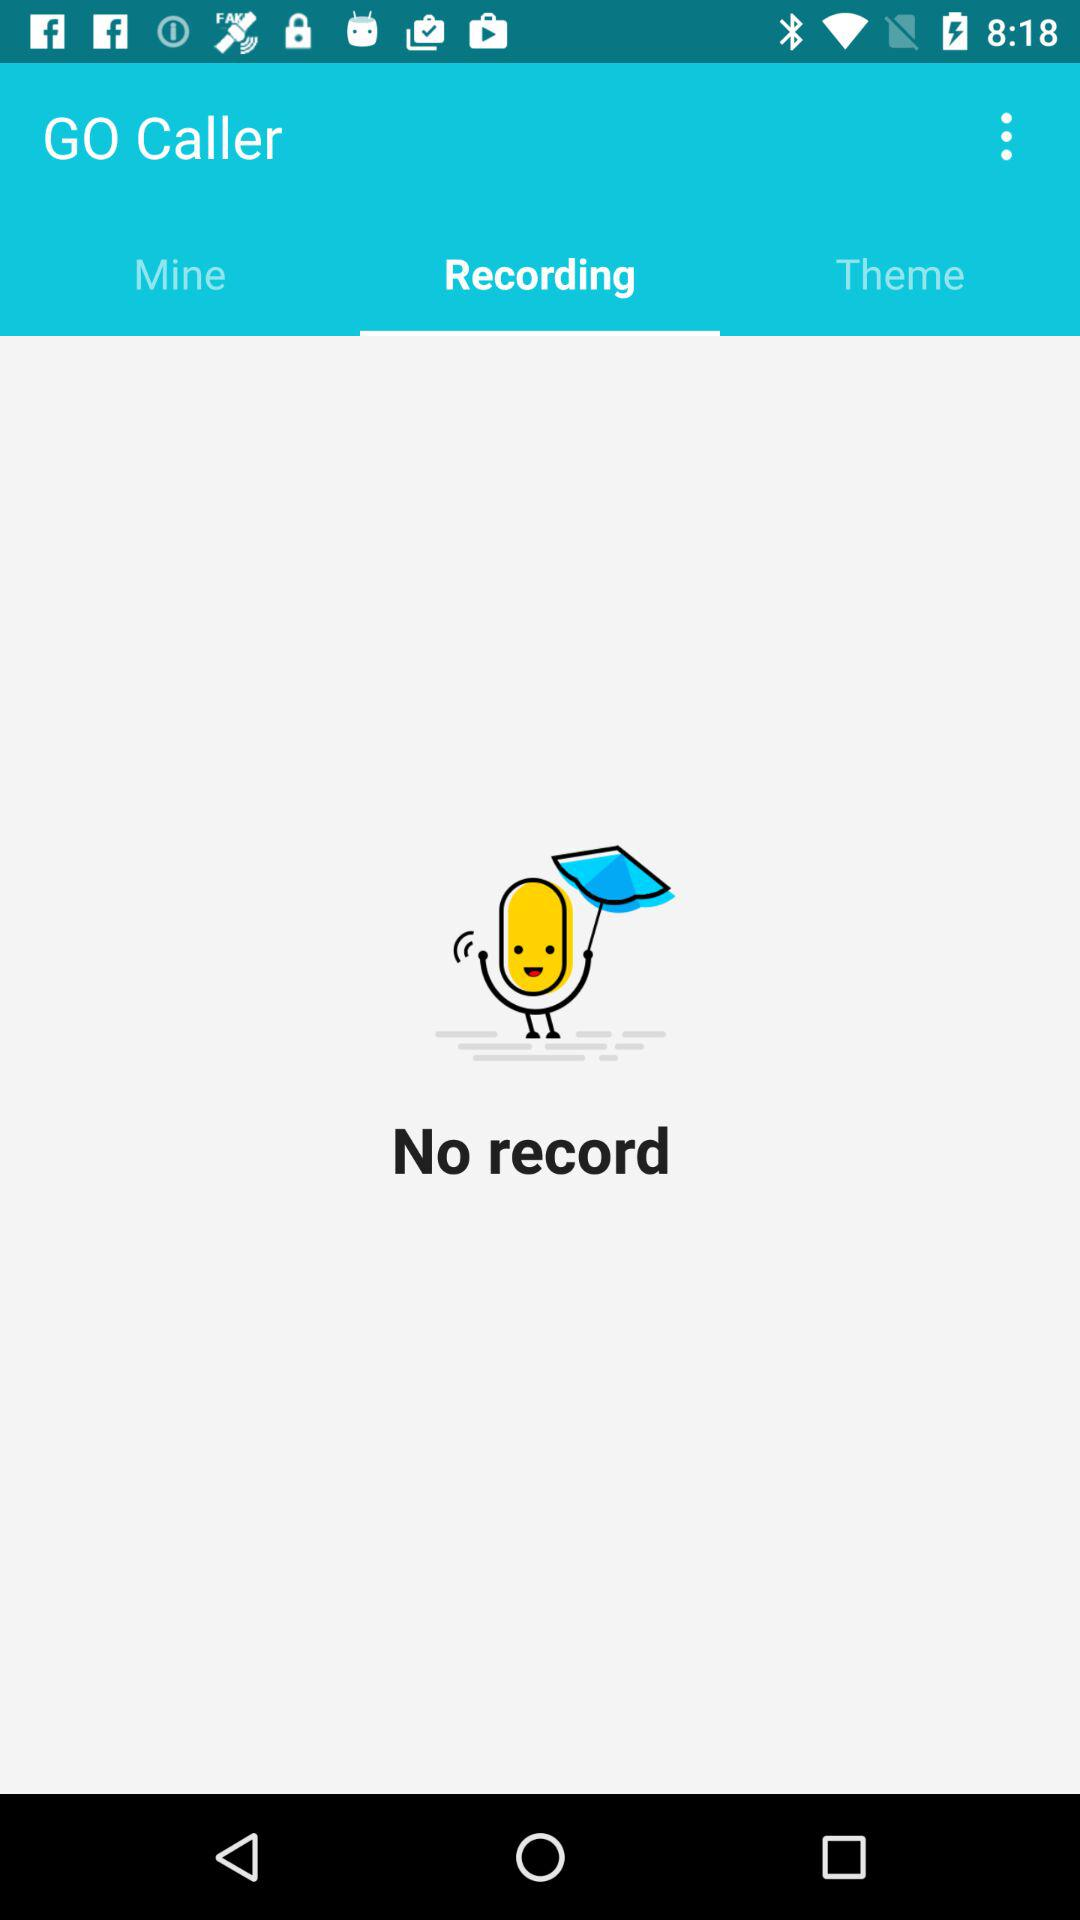What is the name of the application? The name of the application is "GO Caller". 